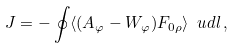<formula> <loc_0><loc_0><loc_500><loc_500>J & = - \oint \langle ( A _ { \varphi } - W _ { \varphi } ) F _ { 0 \rho } \rangle \, \ u d l \, ,</formula> 